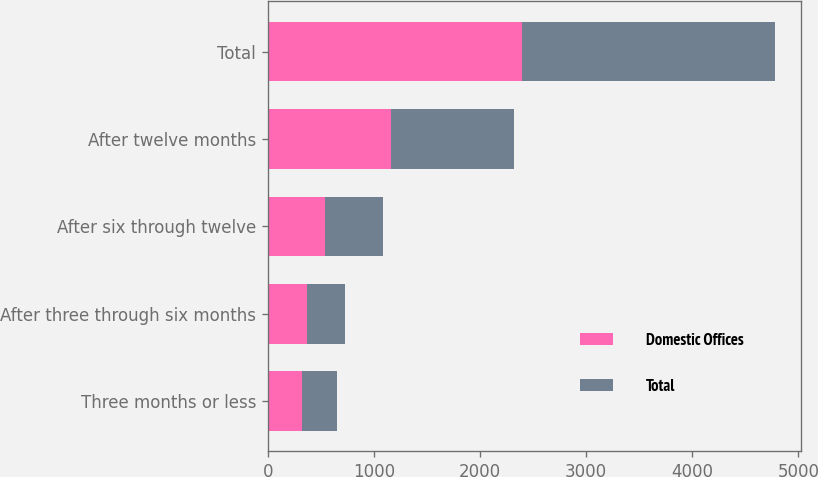Convert chart to OTSL. <chart><loc_0><loc_0><loc_500><loc_500><stacked_bar_chart><ecel><fcel>Three months or less<fcel>After three through six months<fcel>After six through twelve<fcel>After twelve months<fcel>Total<nl><fcel>Domestic Offices<fcel>324<fcel>366<fcel>542<fcel>1160<fcel>2392<nl><fcel>Total<fcel>324<fcel>366<fcel>542<fcel>1160<fcel>2392<nl></chart> 